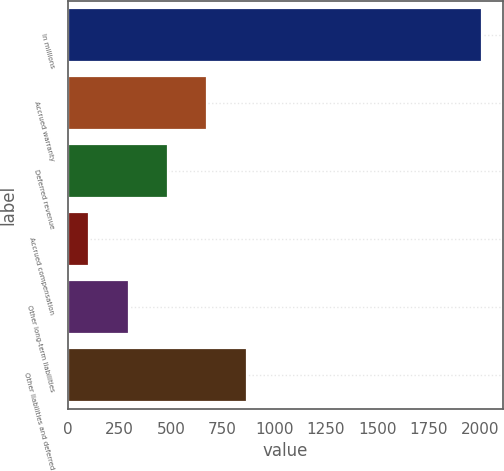<chart> <loc_0><loc_0><loc_500><loc_500><bar_chart><fcel>In millions<fcel>Accrued warranty<fcel>Deferred revenue<fcel>Accrued compensation<fcel>Other long-term liabilities<fcel>Other liabilities and deferred<nl><fcel>2009<fcel>675.5<fcel>485<fcel>104<fcel>294.5<fcel>866<nl></chart> 